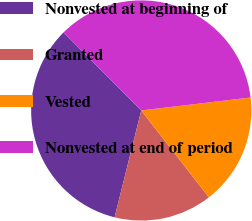<chart> <loc_0><loc_0><loc_500><loc_500><pie_chart><fcel>Nonvested at beginning of<fcel>Granted<fcel>Vested<fcel>Nonvested at end of period<nl><fcel>33.65%<fcel>14.42%<fcel>16.35%<fcel>35.58%<nl></chart> 